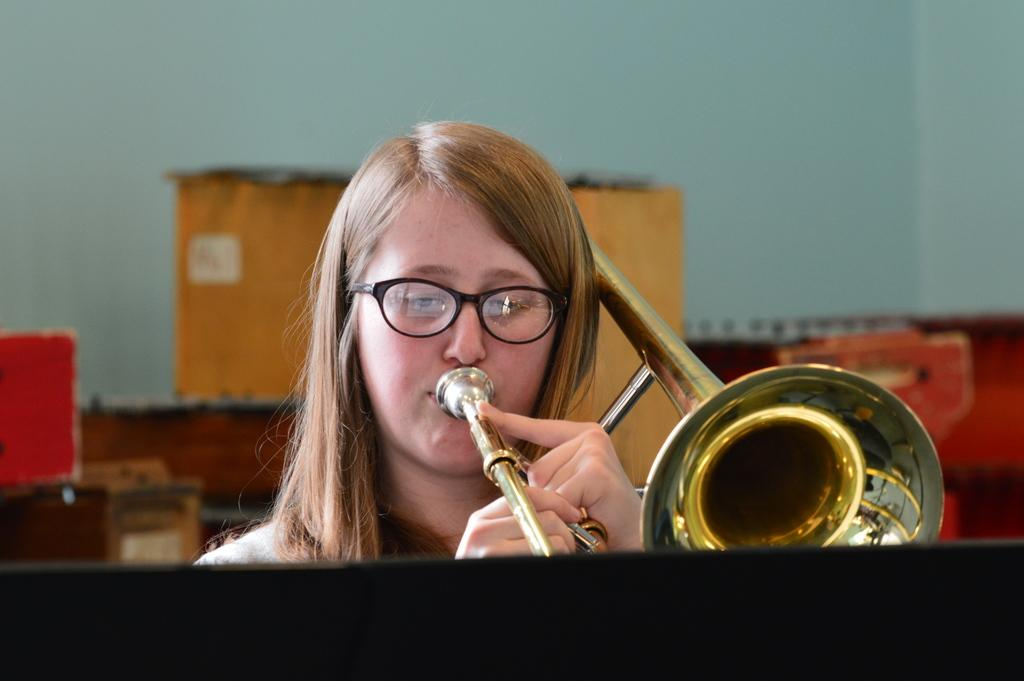Who is present in the image? There is a woman in the image. What is the woman holding in the image? The woman is holding a musical instrument. What can be seen in the background of the image? There is a wall in the background of the image. What type of cheese is being used to make the stew in the image? There is no stew or cheese present in the image; it features a woman holding a musical instrument with a wall in the background. 